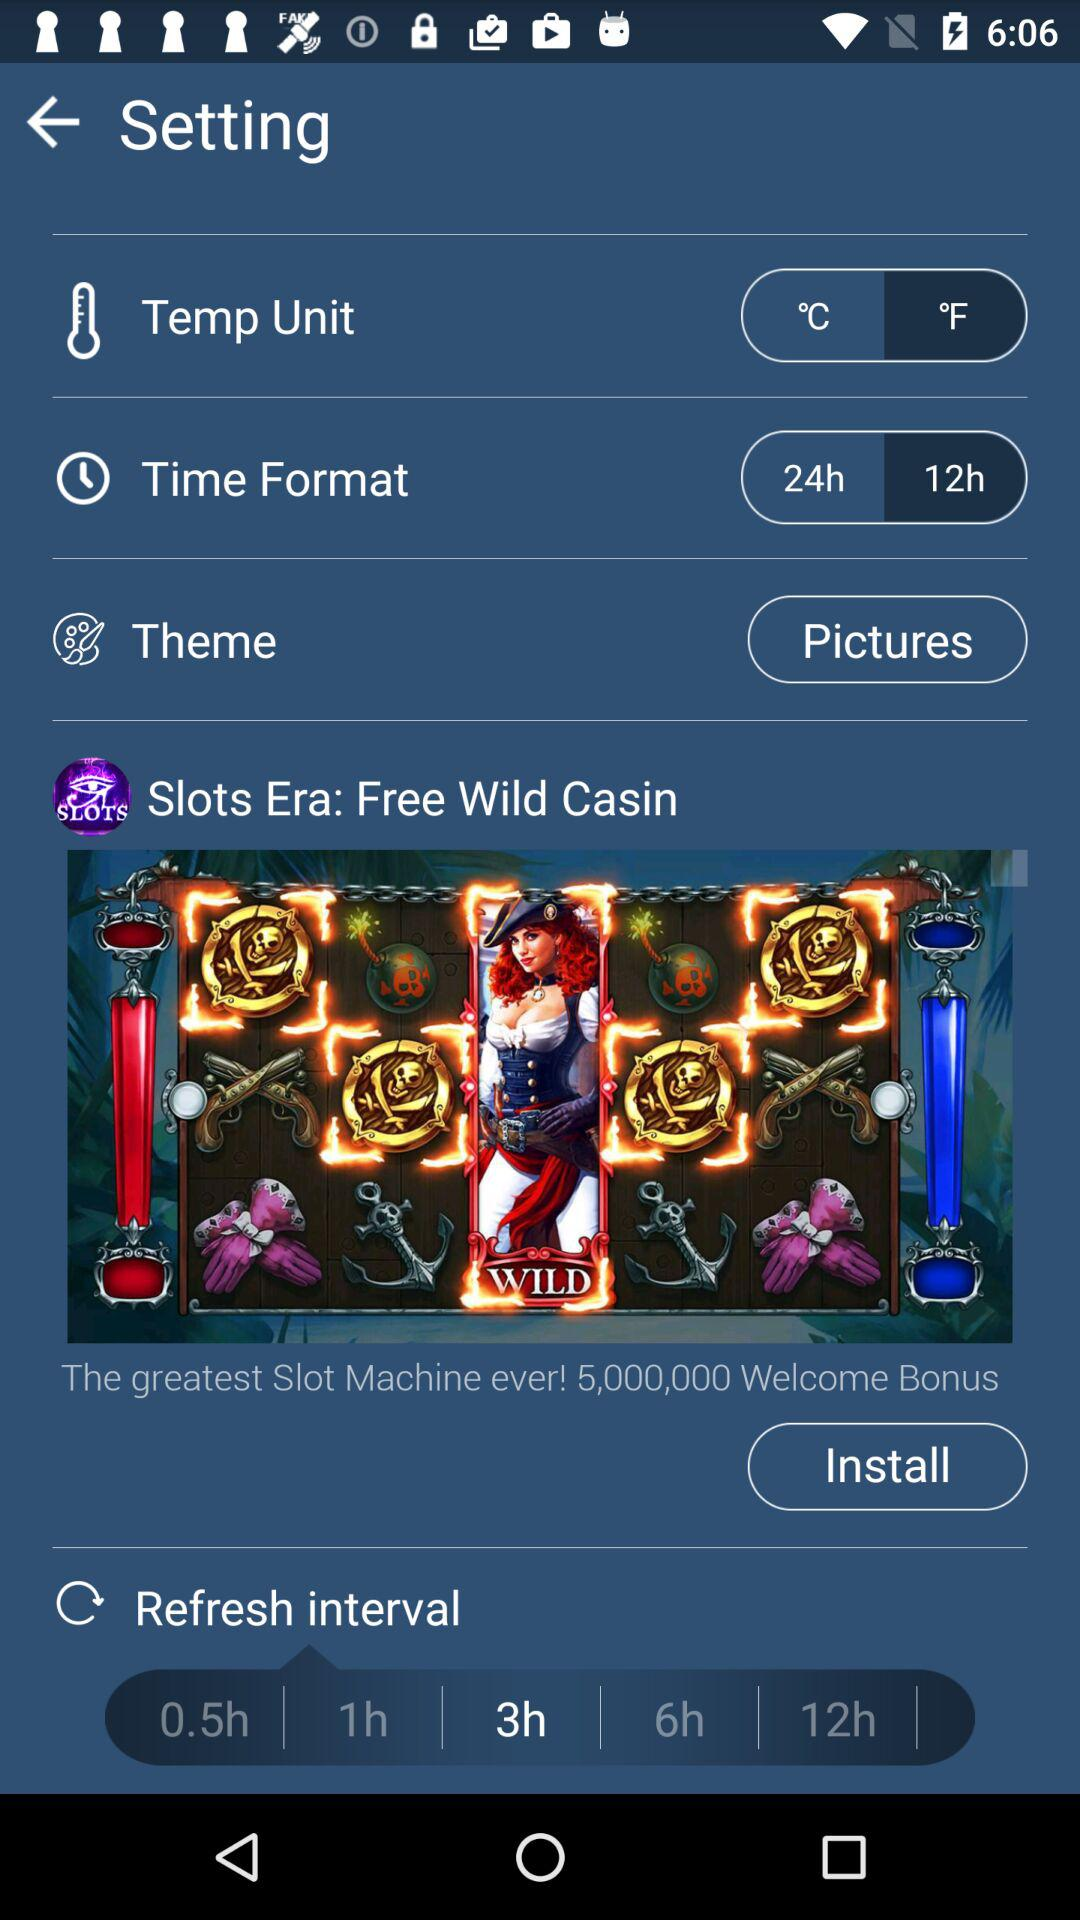What is the value of the welcome bonus? The value is 5,000,000. 